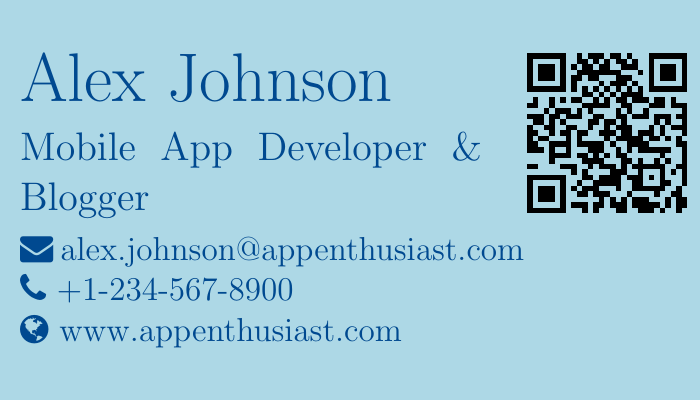what is the name on the business card? The name on the business card is prominently displayed at the top of the document.
Answer: Alex Johnson what is Alex's profession? The document specifies his profession clearly beneath his name.
Answer: Mobile App Developer & Blogger what is the email address provided? The email address is listed in a line typically used for contact information.
Answer: alex.johnson@appenthusiast.com how many specialties are listed on the card? The number of specialties can be counted from the itemized list provided in the document.
Answer: 4 which social media platform is linked to Twitter? The social media items include links to various platforms, and the first one mentioned is for Twitter.
Answer: twitter.com/alexappenthusiast what is the QR code link directing to? The QR code is associated with the website provided in the contact information.
Answer: www.appenthusiast.com which development area is not mentioned in the specialties? By reviewing the listed specialties, one can identify areas not included.
Answer: Web Development what color is the background of the business card? The background color is specified in the document’s settings and showcases the card's design.
Answer: Light Blue is there a professional headshot included? The structure of the business card layout does not indicate a professional headshot.
Answer: No 